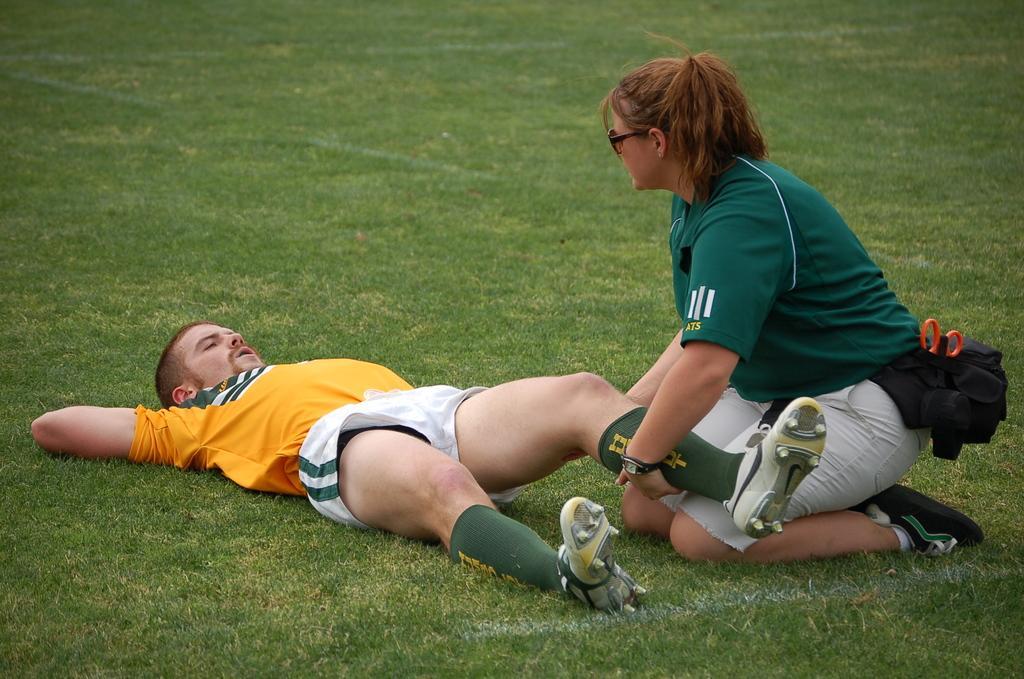Could you give a brief overview of what you see in this image? In this image we can see two persons on the ground, among them one is lying on the ground and the other one is sitting and holding a person. 